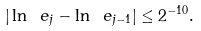<formula> <loc_0><loc_0><loc_500><loc_500>| \ln \ e _ { j } - \ln \ e _ { j - 1 } | \leq 2 ^ { - 1 0 } .</formula> 